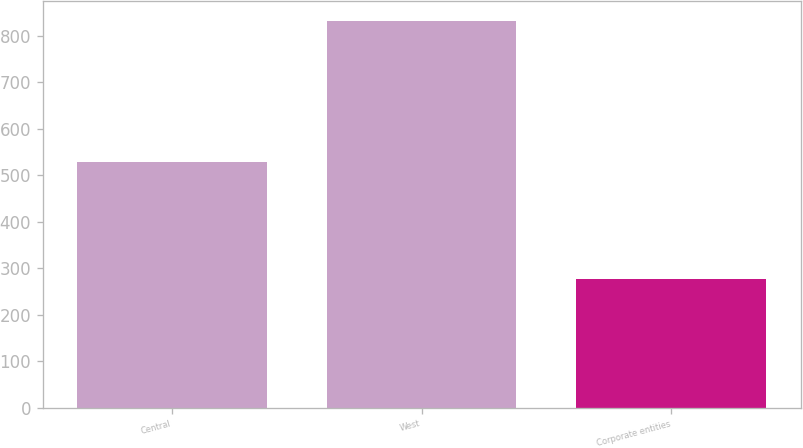Convert chart. <chart><loc_0><loc_0><loc_500><loc_500><bar_chart><fcel>Central<fcel>West<fcel>Corporate entities<nl><fcel>527.7<fcel>832.4<fcel>276.3<nl></chart> 